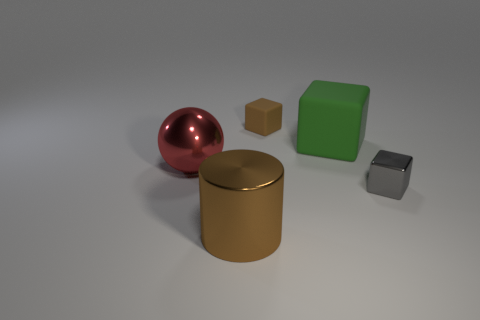Add 2 big red metallic cylinders. How many objects exist? 7 Subtract all balls. How many objects are left? 4 Subtract 0 gray cylinders. How many objects are left? 5 Subtract all green rubber things. Subtract all green objects. How many objects are left? 3 Add 5 tiny matte objects. How many tiny matte objects are left? 6 Add 4 small gray metal objects. How many small gray metal objects exist? 5 